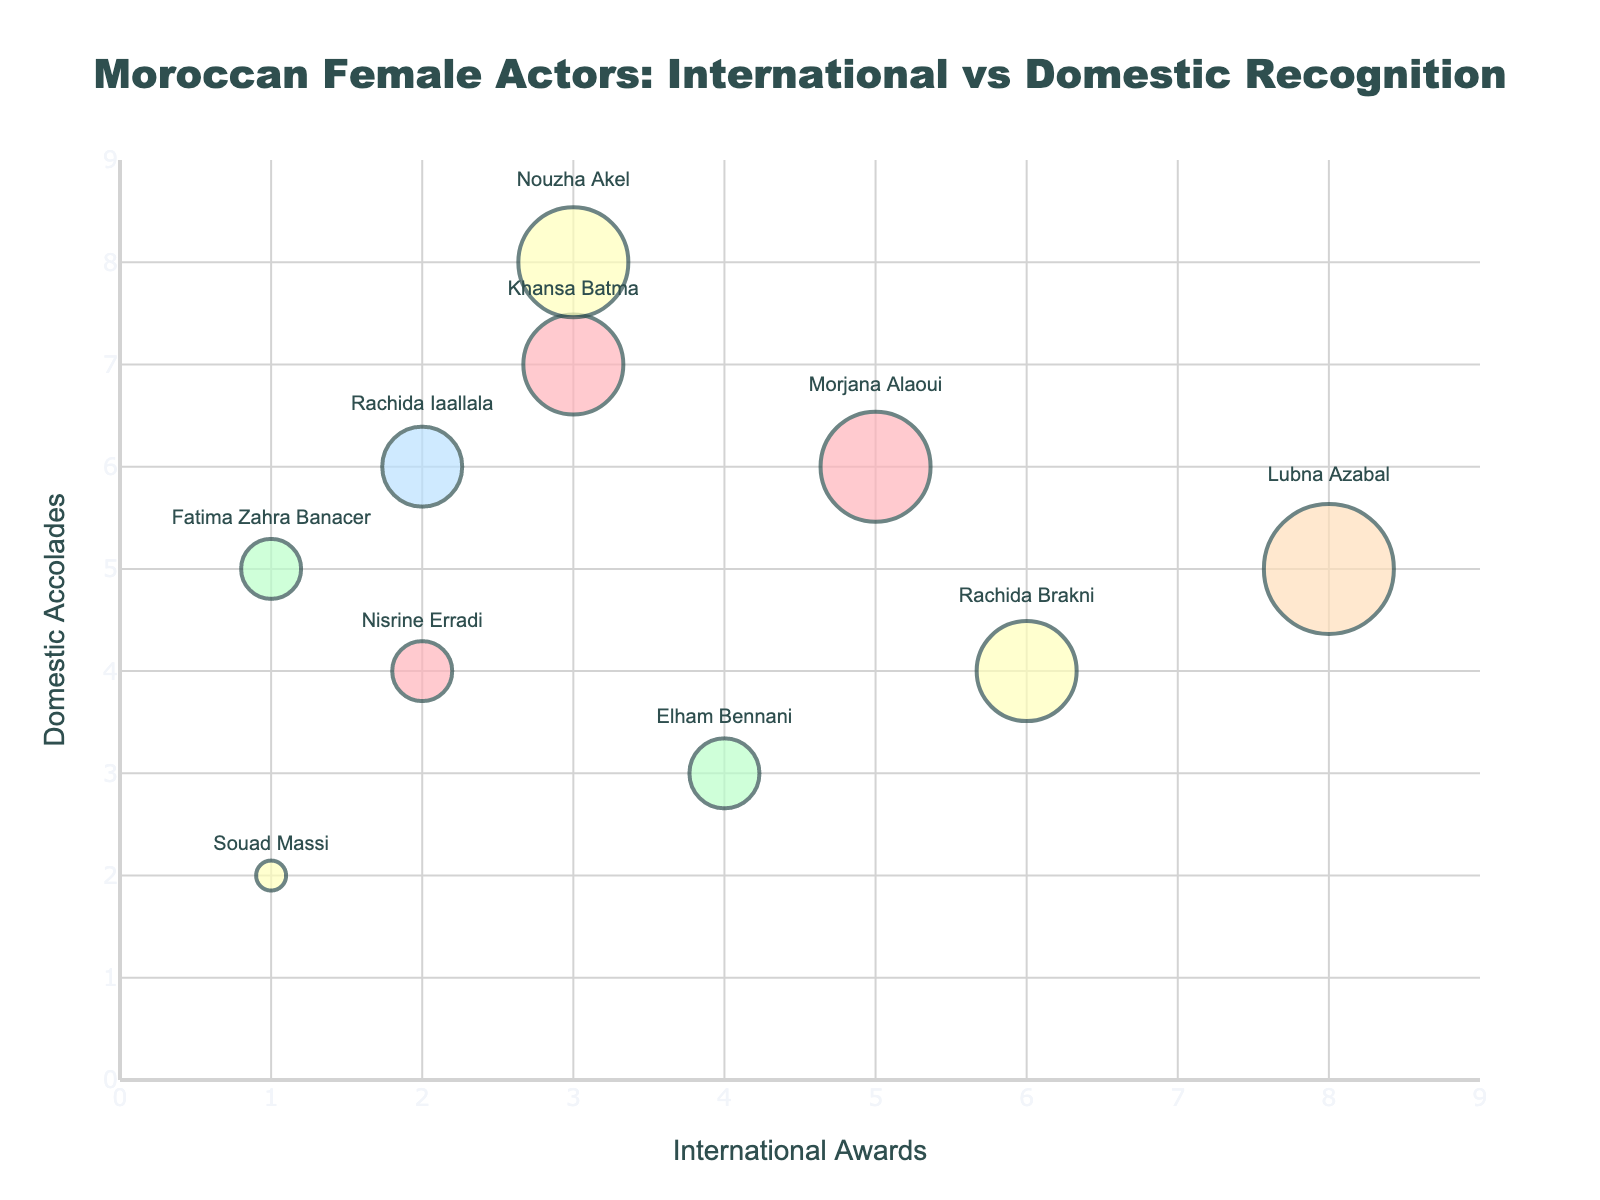What is the title of the bubble chart? The title of a bubble chart is generally located at the top and it provides a quick understanding of what the chart is about.
Answer: Moroccan Female Actors: International vs Domestic Recognition How many Moroccan female actors have more than 5 international awards? By counting the actors from the figure who have international awards greater than 5, we can identify them. Lubna Azabal (8) and Rachida Brakni (6) meet this criterion.
Answer: 2 Who has the largest bubble size and what does it indicate? The largest bubble size can be identified by visually finding the biggest bubble in the chart. This is Lubna Azabal. The bubble size generally correlates to the overall number of combined awards or other criteria mentioned, suggesting Lubna has the highest overall recognition.
Answer: Lubna Azabal Which actor has the highest number of domestic accolades? To find this actor, we locate the point farthest along the Domestic Accolades axis. Nouzha Akel, with 8 domestic accolades, is this person.
Answer: Nouzha Akel Between Khansa Batma and Lubna Azabal, who has more international awards? By comparing the x-axis values for both Khansa Batma (3) and Lubna Azabal (8), Lubna Azabal has more international awards.
Answer: Lubna Azabal How many actors receive higher domestic accolades than international awards? Compare each actor’s domestic accolades against their international awards. The actors who meet this are: Khansa Batma, Fatima Zahra Banacer, Elham Bennani, Rachida Iaallala, Souad Massi. There are 5 such actors.
Answer: 5 Who has exactly 4 international awards and how many domestic accolades does this actor have? Look for the data point corresponding to 4 on the x-axis. Elham Bennani is the actor with 4 international awards. Elham Bennani has 3 domestic accolades.
Answer: Elham Bennani has 3 Is there any actor who has received equal number of international awards and domestic accolades? By checking if any data points align equally on both axes (x = y), we determine that no actors have equal international awards and domestic accolades based on the given data points in the figure.
Answer: No Which actor has the smallest bubble size and how many domestic accolades does she have? The smallest bubble size visually and from data (with size 3) is for Souad Massi. Souad Massi has 2 domestic accolades.
Answer: Souad Massi has 2 Between Morjana Alaoui and Khansa Batma, who has more total accolades (sum of international and domestic)? Add the international awards and domestic accolades for both. Morjana Alaoui: 5 + 6 = 11, Khansa Batma: 3 + 7 = 10. Morjana Alaoui has more.
Answer: Morjana Alaoui 